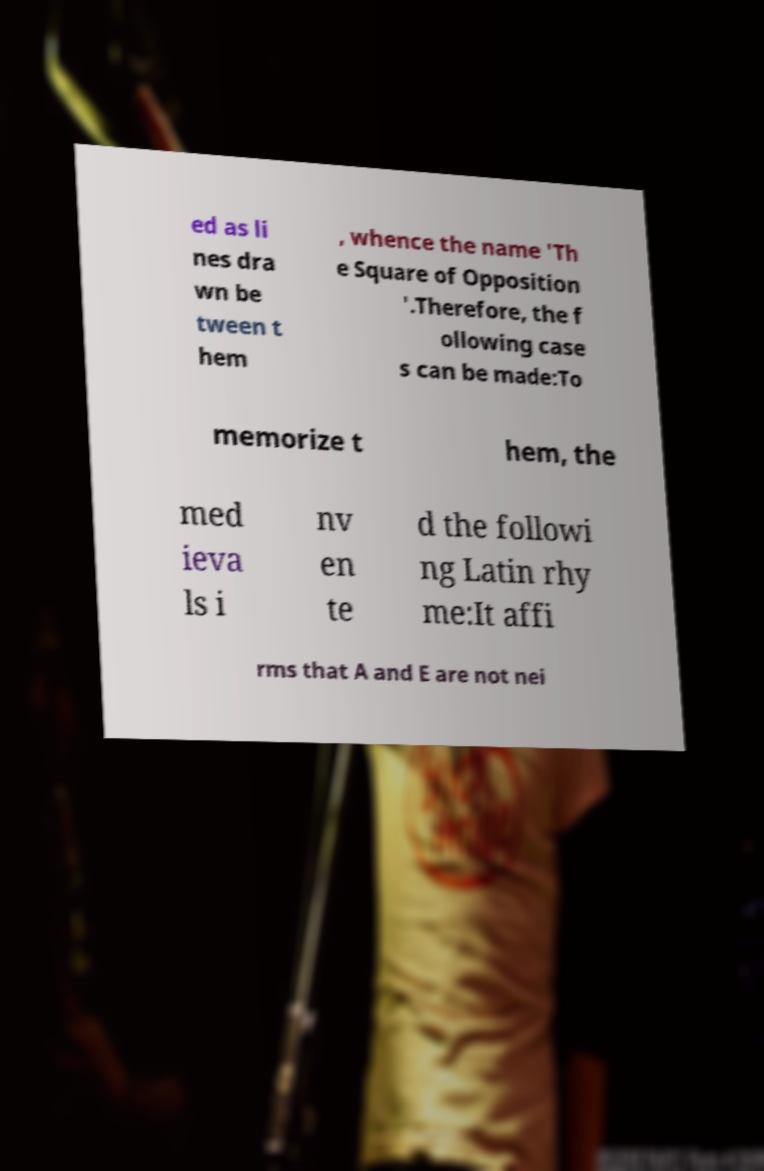There's text embedded in this image that I need extracted. Can you transcribe it verbatim? ed as li nes dra wn be tween t hem , whence the name 'Th e Square of Opposition '.Therefore, the f ollowing case s can be made:To memorize t hem, the med ieva ls i nv en te d the followi ng Latin rhy me:It affi rms that A and E are not nei 